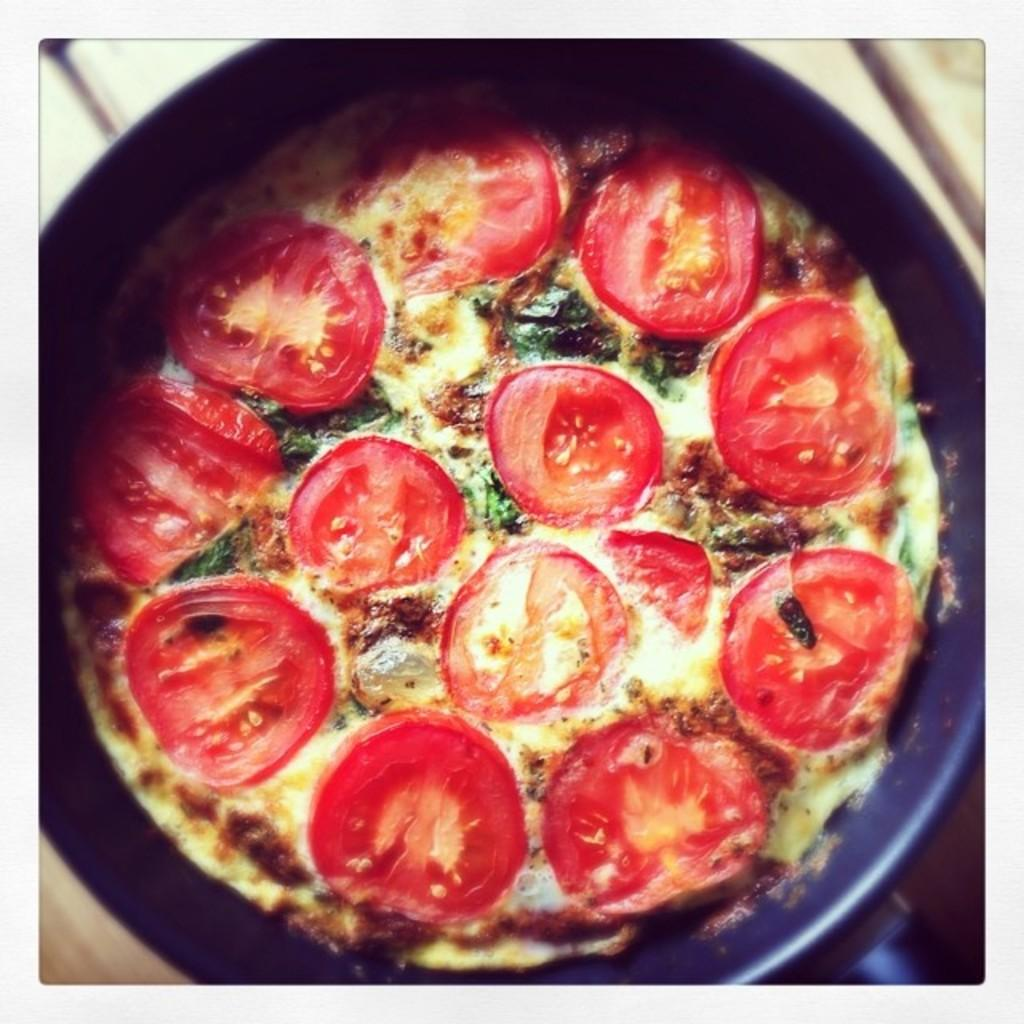What is present in the image that can hold food? There is a bowl in the image that can hold food. What type of food item is in the bowl? There is a food item in the bowl, but the specific type is not mentioned in the facts. Can you describe the background of the image? The background of the image is blurred. What force is being applied to the coat in the image? There is no coat present in the image, so no force can be applied to it. 